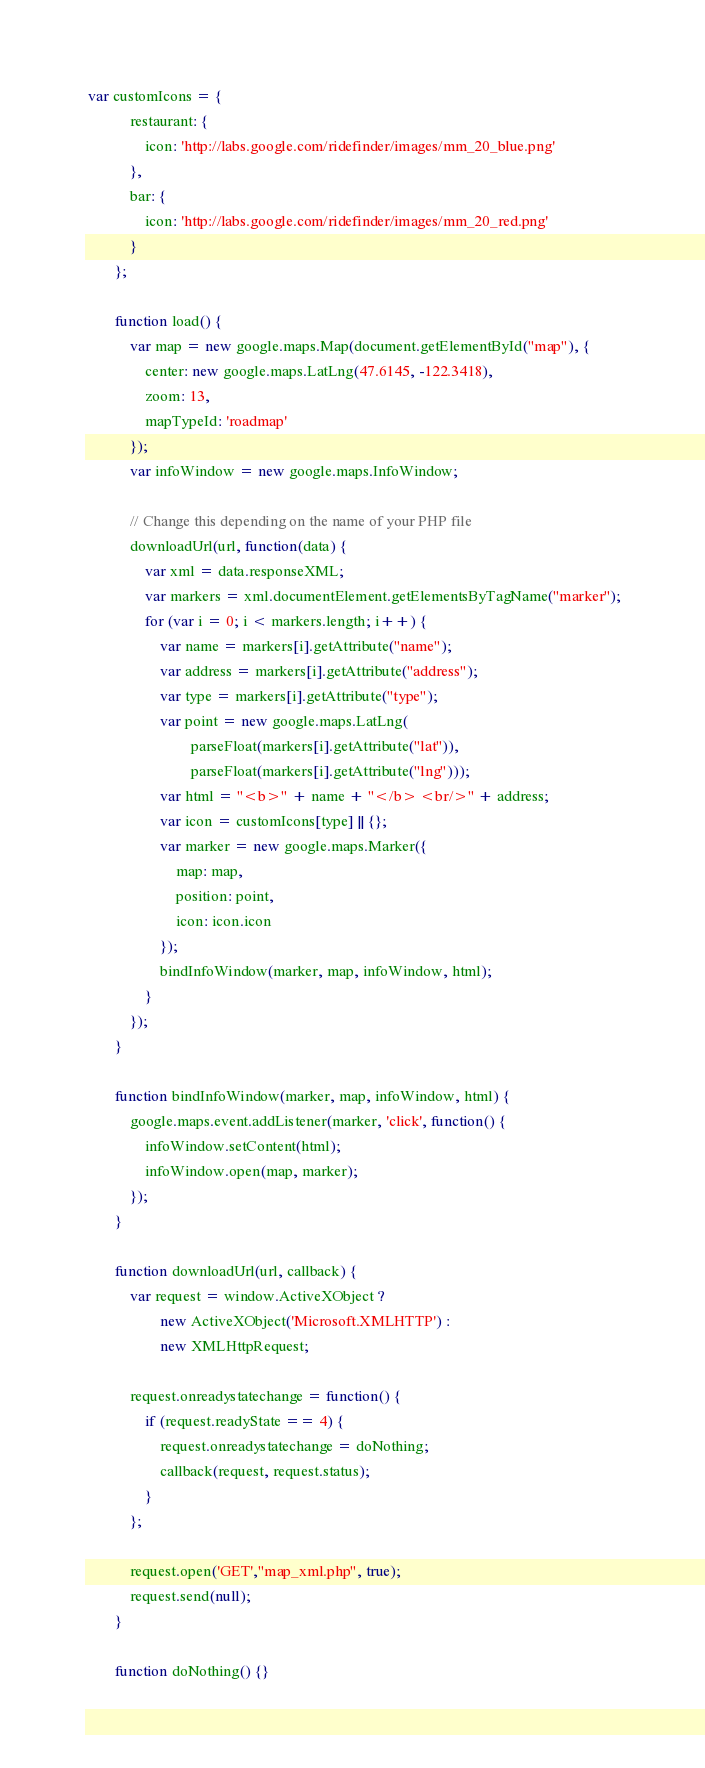<code> <loc_0><loc_0><loc_500><loc_500><_JavaScript_> var customIcons = {
            restaurant: {
                icon: 'http://labs.google.com/ridefinder/images/mm_20_blue.png'
            },
            bar: {
                icon: 'http://labs.google.com/ridefinder/images/mm_20_red.png'
            }
        };

        function load() {
            var map = new google.maps.Map(document.getElementById("map"), {
                center: new google.maps.LatLng(47.6145, -122.3418),
                zoom: 13,
                mapTypeId: 'roadmap'
            });
            var infoWindow = new google.maps.InfoWindow;

            // Change this depending on the name of your PHP file
            downloadUrl(url, function(data) {
                var xml = data.responseXML;
                var markers = xml.documentElement.getElementsByTagName("marker");
                for (var i = 0; i < markers.length; i++) {
                    var name = markers[i].getAttribute("name");
                    var address = markers[i].getAttribute("address");
                    var type = markers[i].getAttribute("type");
                    var point = new google.maps.LatLng(
                            parseFloat(markers[i].getAttribute("lat")),
                            parseFloat(markers[i].getAttribute("lng")));
                    var html = "<b>" + name + "</b> <br/>" + address;
                    var icon = customIcons[type] || {};
                    var marker = new google.maps.Marker({
                        map: map,
                        position: point,
                        icon: icon.icon
                    });
                    bindInfoWindow(marker, map, infoWindow, html);
                }
            });
        }

        function bindInfoWindow(marker, map, infoWindow, html) {
            google.maps.event.addListener(marker, 'click', function() {
                infoWindow.setContent(html);
                infoWindow.open(map, marker);
            });
        }

        function downloadUrl(url, callback) {
            var request = window.ActiveXObject ?
                    new ActiveXObject('Microsoft.XMLHTTP') :
                    new XMLHttpRequest;

            request.onreadystatechange = function() {
                if (request.readyState == 4) {
                    request.onreadystatechange = doNothing;
                    callback(request, request.status);
                }
            };

            request.open('GET',"map_xml.php", true);
            request.send(null);
        }

        function doNothing() {}

</code> 